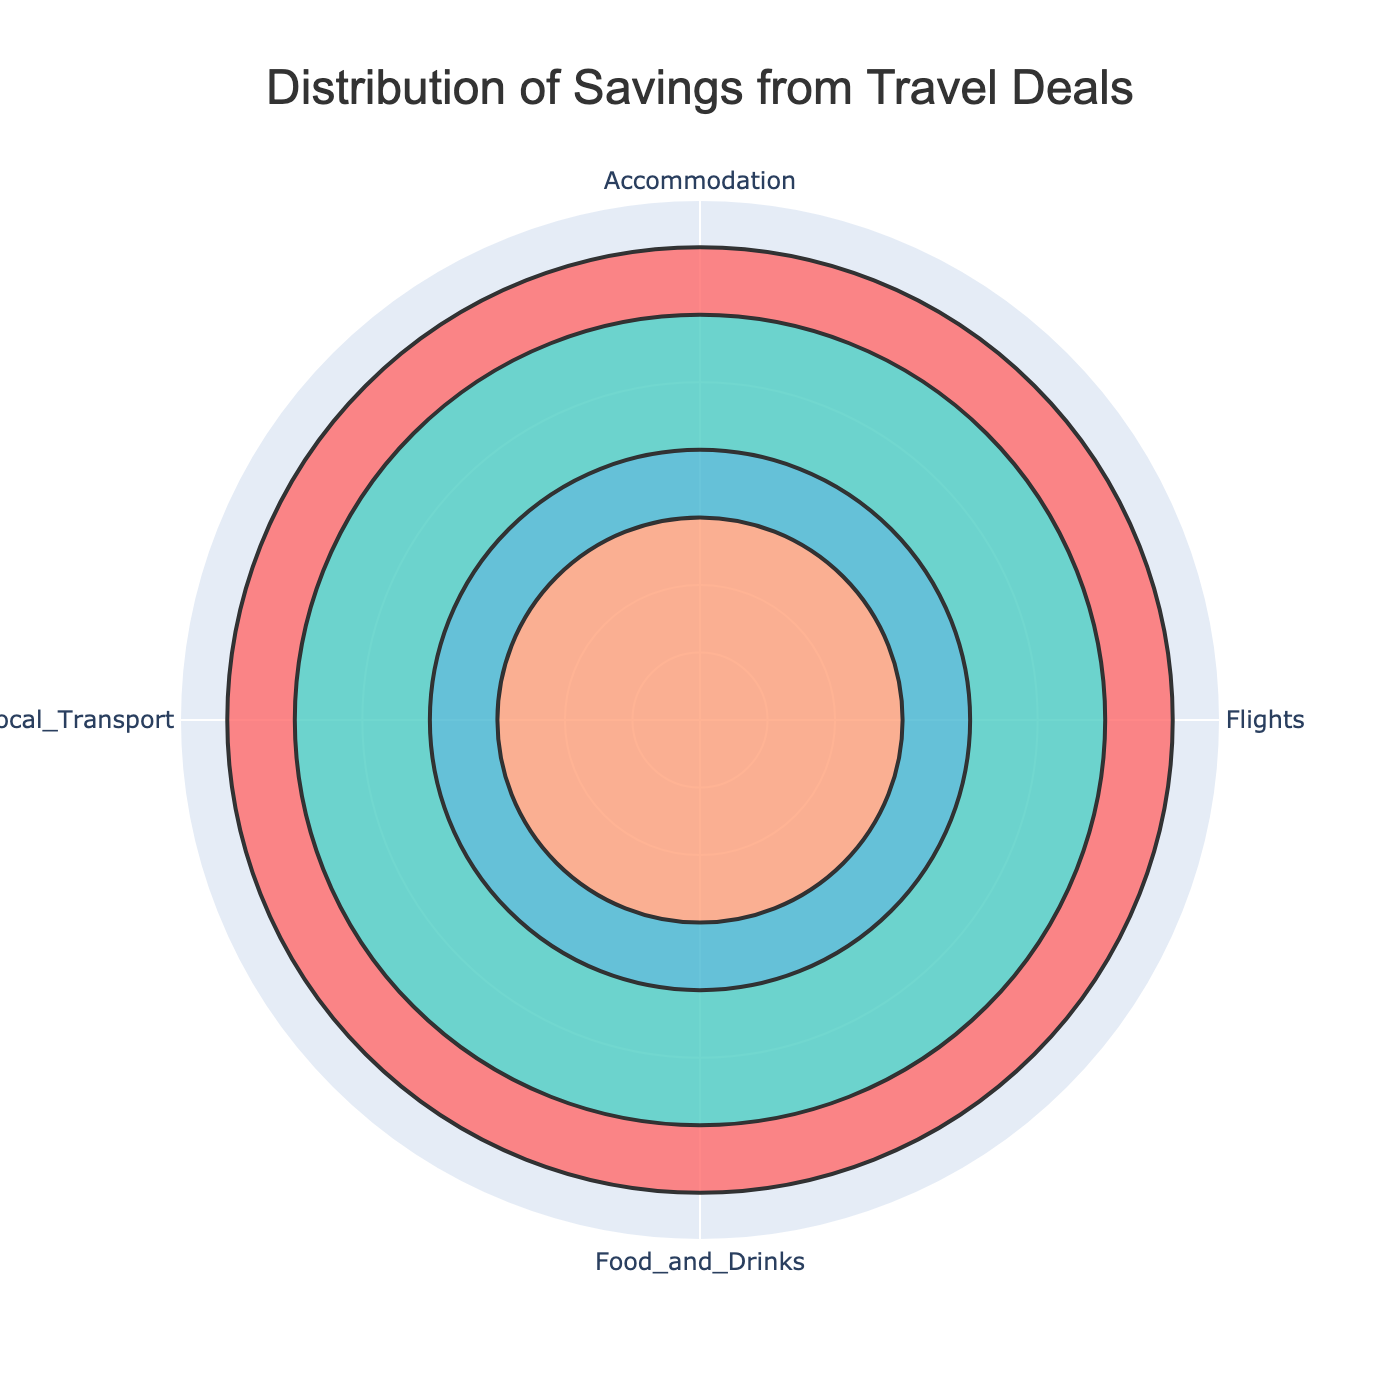Which category offers the highest percentage saving? By looking at the lengths of the bars and their radial distance, Accommodation has the longest bar, thus the highest percentage saving.
Answer: Accommodation Which category offers the lowest percentage saving? By examining the lengths of the bars, Local Transport has the shortest bar, thus the lowest percentage saving.
Answer: Local Transport How much more can you save on Accommodation compared to Flights? Accommodation offers a saving of 35%, while Flights offer 30%. The difference is 35% - 30%.
Answer: 5% What is the total percentage saving for Food and Drinks and Local Transport combined? Food and Drinks offer a saving of 20%, and Local Transport offers 15%. Combined, this is 20% + 15%.
Answer: 35% You're planning a trip and can only choose two discounts, which combination would maximize your savings? The two highest percentages are Accommodation (35%) and Flights (30%). Together, they give 35% + 30%.
Answer: Accommodation and Flights Which category has a saving percentage that is closest to 20%? By inspecting the chart, Food and Drinks has a saving percentage of 20%, which is exactly 20%.
Answer: Food and Drinks If an area of the plot represents the percentage distribution, which region (category) has an angular span less than 90 degrees? The total angle is divided according to the percentage saving. Local Transport has a saving of 15%, which translates to an angular span (15/100)*360 = 54 degrees.
Answer: Local Transport Does any category save more than one-third of the total savings? One-third of the total savings is about 33.33%. Accommodation saves 35%, which is more than one-third.
Answer: Yes, Accommodation Which category’s saving is half of the combined savings of Flights and Local Transport? The combined savings of Flights and Local Transport are 30% + 15% = 45%. Half of this is 22.5%. None of the categories have a saving that is exactly 22.5%, so the closest is Food and Drinks with 20%.
Answer: Food and Drinks (closest) How does the saving from Food and Drinks compare to that of Flights? Food and Drinks offer 20% savings, while Flights offer 30%. Flights’ savings are 10% higher than Food and Drinks'.
Answer: 10% higher 